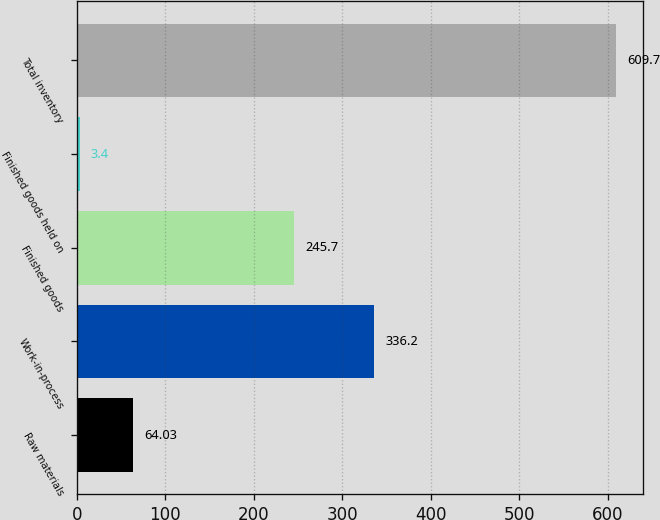Convert chart. <chart><loc_0><loc_0><loc_500><loc_500><bar_chart><fcel>Raw materials<fcel>Work-in-process<fcel>Finished goods<fcel>Finished goods held on<fcel>Total inventory<nl><fcel>64.03<fcel>336.2<fcel>245.7<fcel>3.4<fcel>609.7<nl></chart> 